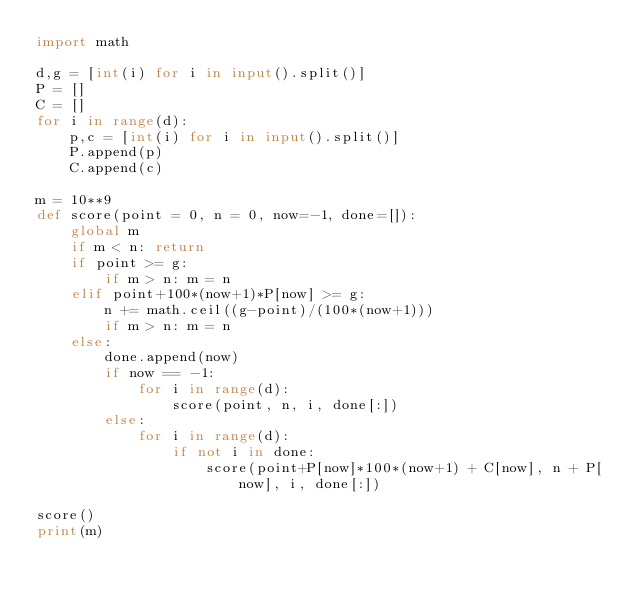Convert code to text. <code><loc_0><loc_0><loc_500><loc_500><_Python_>import math
 
d,g = [int(i) for i in input().split()]
P = []
C = []
for i in range(d):
    p,c = [int(i) for i in input().split()]
    P.append(p)
    C.append(c)
 
m = 10**9
def score(point = 0, n = 0, now=-1, done=[]):
    global m
    if m < n: return
    if point >= g:
        if m > n: m = n
    elif point+100*(now+1)*P[now] >= g:
        n += math.ceil((g-point)/(100*(now+1)))
        if m > n: m = n
    else:
        done.append(now)
        if now == -1:
            for i in range(d):
                score(point, n, i, done[:])
        else:
            for i in range(d):
                if not i in done:
                    score(point+P[now]*100*(now+1) + C[now], n + P[now], i, done[:])

score()
print(m)</code> 